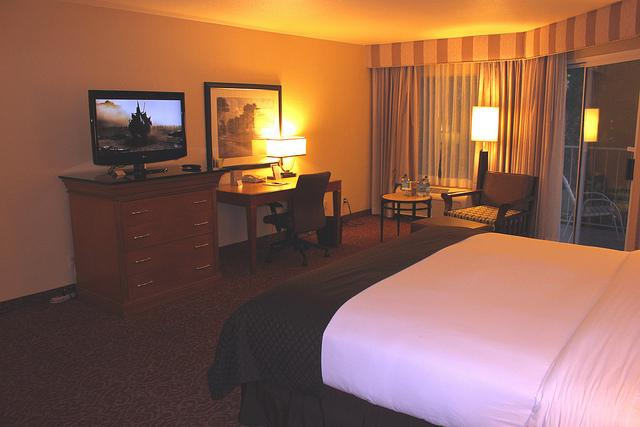What are in the bottles on the right? water 